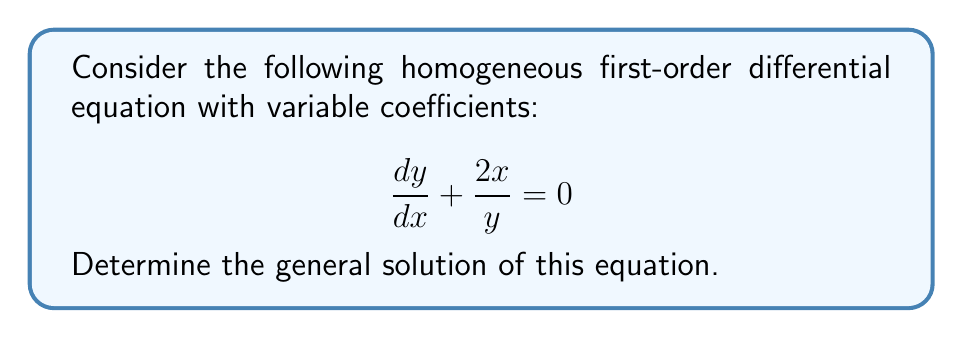Provide a solution to this math problem. To solve this homogeneous first-order differential equation with variable coefficients, we'll follow these steps:

1) First, recognize that this equation is in the form:
   $$ \frac{dy}{dx} = -\frac{2x}{y} $$

2) This equation is separable. Let's rearrange it to separate variables:
   $$ y dy = -2x dx $$

3) Now, integrate both sides:
   $$ \int y dy = -2 \int x dx $$

4) Evaluate the integrals:
   $$ \frac{1}{2}y^2 = -x^2 + C $$
   where $C$ is an arbitrary constant of integration.

5) Solve for $y$:
   $$ y^2 = -2x^2 + 2C $$
   $$ y = \pm \sqrt{-2x^2 + 2C} $$

6) To simplify, let's introduce a new arbitrary constant $k = \sqrt{2C}$. This gives us:
   $$ y = \pm \sqrt{k^2 - 2x^2} $$

This is the general solution of the given differential equation.
Answer: The general solution is:
$$ y = \pm \sqrt{k^2 - 2x^2} $$
where $k$ is an arbitrary constant. 